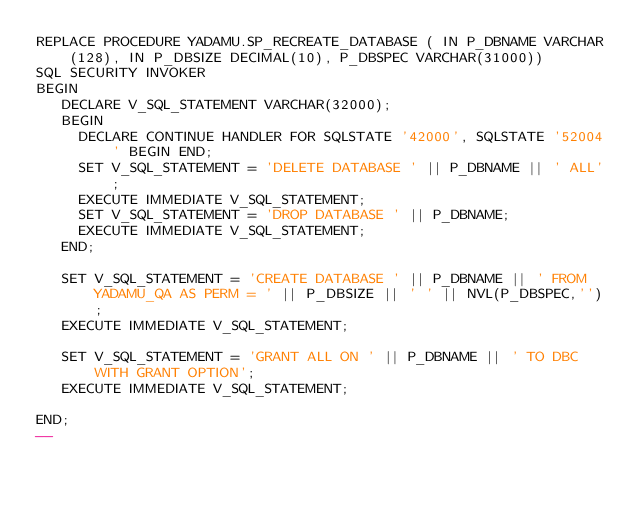<code> <loc_0><loc_0><loc_500><loc_500><_SQL_>REPLACE PROCEDURE YADAMU.SP_RECREATE_DATABASE ( IN P_DBNAME VARCHAR(128), IN P_DBSIZE DECIMAL(10), P_DBSPEC VARCHAR(31000))
SQL SECURITY INVOKER
BEGIN
   DECLARE V_SQL_STATEMENT VARCHAR(32000);
   BEGIN
     DECLARE CONTINUE HANDLER FOR SQLSTATE '42000', SQLSTATE '52004' BEGIN END;
     SET V_SQL_STATEMENT = 'DELETE DATABASE ' || P_DBNAME || ' ALL';
     EXECUTE IMMEDIATE V_SQL_STATEMENT;
     SET V_SQL_STATEMENT = 'DROP DATABASE ' || P_DBNAME;
     EXECUTE IMMEDIATE V_SQL_STATEMENT;
   END;

   SET V_SQL_STATEMENT = 'CREATE DATABASE ' || P_DBNAME || ' FROM YADAMU_QA AS PERM = ' || P_DBSIZE || ' ' || NVL(P_DBSPEC,'');
   EXECUTE IMMEDIATE V_SQL_STATEMENT;

   SET V_SQL_STATEMENT = 'GRANT ALL ON ' || P_DBNAME || ' TO DBC WITH GRANT OPTION';
   EXECUTE IMMEDIATE V_SQL_STATEMENT;

END;
--</code> 